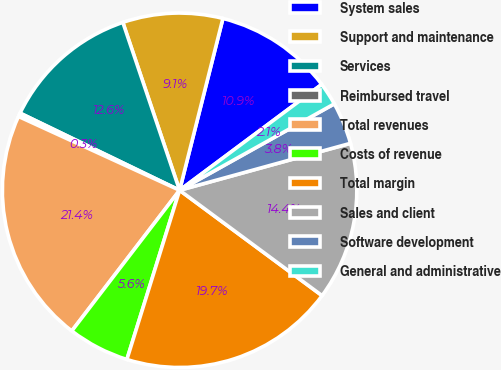<chart> <loc_0><loc_0><loc_500><loc_500><pie_chart><fcel>System sales<fcel>Support and maintenance<fcel>Services<fcel>Reimbursed travel<fcel>Total revenues<fcel>Costs of revenue<fcel>Total margin<fcel>Sales and client<fcel>Software development<fcel>General and administrative<nl><fcel>10.88%<fcel>9.12%<fcel>12.64%<fcel>0.33%<fcel>21.43%<fcel>5.6%<fcel>19.67%<fcel>14.4%<fcel>3.84%<fcel>2.08%<nl></chart> 